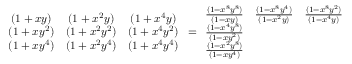<formula> <loc_0><loc_0><loc_500><loc_500>\begin{array} { c c c } { ( 1 + x y ) } & { ( 1 + x ^ { 2 } y ) } & { ( 1 + x ^ { 4 } y ) } \\ { ( 1 + x y ^ { 2 } ) } & { ( 1 + x ^ { 2 } y ^ { 2 } ) } & { ( 1 + x ^ { 4 } y ^ { 2 } ) } \\ { ( 1 + x y ^ { 4 } ) } & { ( 1 + x ^ { 2 } y ^ { 4 } ) } & { ( 1 + x ^ { 4 } y ^ { 4 } ) } \end{array} = \begin{array} { c c c } { \frac { ( 1 - x ^ { 8 } y ^ { 8 } ) } { ( 1 - x y ) } } & { \frac { ( 1 - x ^ { 8 } y ^ { 4 } ) } { ( 1 - x ^ { 2 } y ) } } & { \frac { ( 1 - x ^ { 8 } y ^ { 2 } ) } { ( 1 - x ^ { 4 } y ) } } \\ { \frac { ( 1 - x ^ { 4 } y ^ { 8 } ) } { ( 1 - x y ^ { 2 } ) } } & & \\ { \frac { ( 1 - x ^ { 2 } y ^ { 8 } ) } { ( 1 - x y ^ { 4 } ) } } & & \end{array}</formula> 